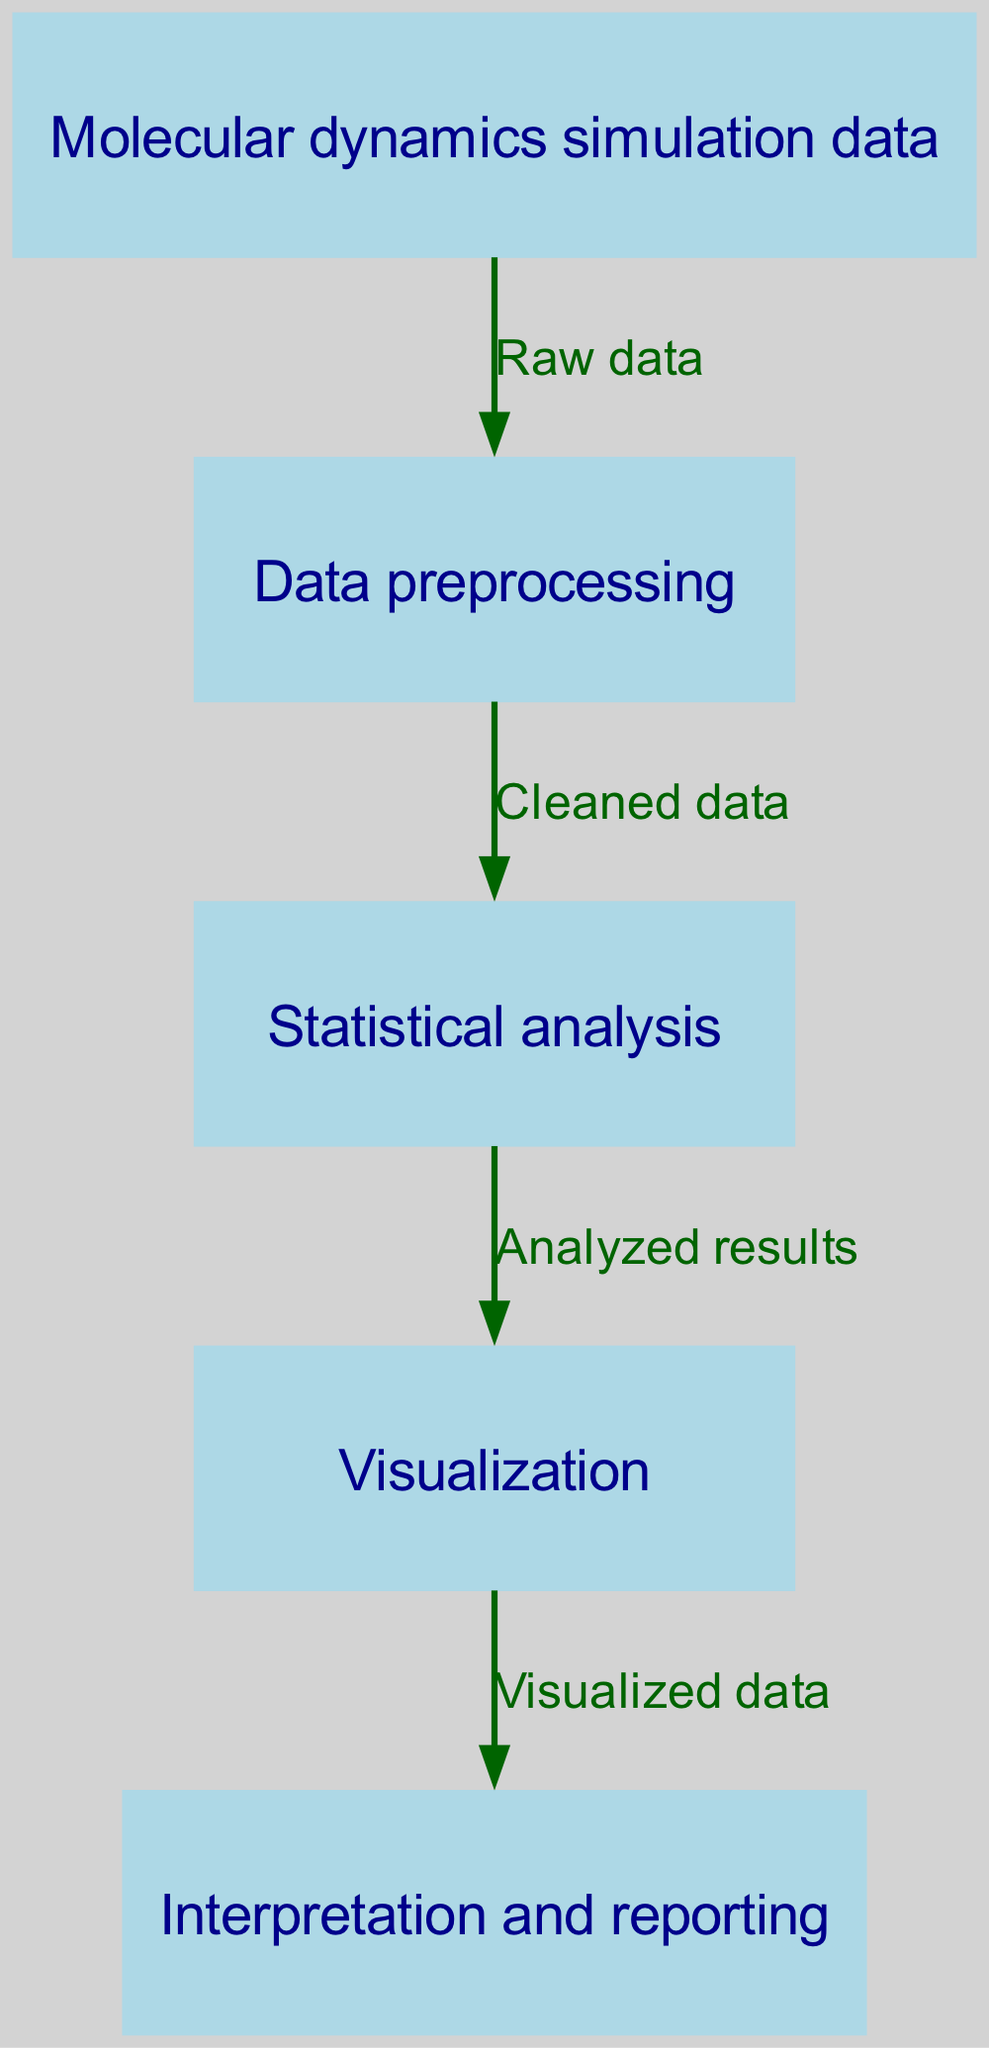What is the starting point of the workflow? The starting point is indicated in the diagram as the first node, which represents the input data for the analysis. In this case, it is "Molecular dynamics simulation data".
Answer: Molecular dynamics simulation data How many nodes are in the diagram? By counting the individual elements labeled in the diagram, we find there are five distinct nodes representing different stages of the workflow.
Answer: 5 What is the output of the "Data preprocessing" node? The "Data preprocessing" node produces an output, as indicated by the outgoing arrow, labeled "Cleaned data". This is a direct representation of the processed information.
Answer: Cleaned data Which node follows the "Statistical analysis" step? The diagram shows a directed connection from the "Statistical analysis" node to the next node, which is "Visualization". This indicates the sequential flow from one process to another.
Answer: Visualization What is the last step in the workflow? The last node in the diagram indicates the final output stage of the workflow, which is "Interpretation and reporting". This marks the end of the data analysis process.
Answer: Interpretation and reporting What is the relationship between the "Molecular dynamics simulation data" and "Data preprocessing" nodes? The diagram connects these two nodes with an edge indicating that the "Data preprocessing" node receives "Raw data" from the "Molecular dynamics simulation data". This reflects a direct flow of information.
Answer: Raw data What type of analysis follows data preprocessing? The workflow indicates that after data preprocessing, the subsequent analysis is labeled as "Statistical analysis". This is shown by the directed arrow leading from one node to the next.
Answer: Statistical analysis What are the visual indicators used to represent nodes in the diagram? The nodes in the diagram are depicted as rectangles filled with a light blue color, with specific style attributes assigned to their appearance, such as font and color settings.
Answer: Rectangles filled with light blue color 